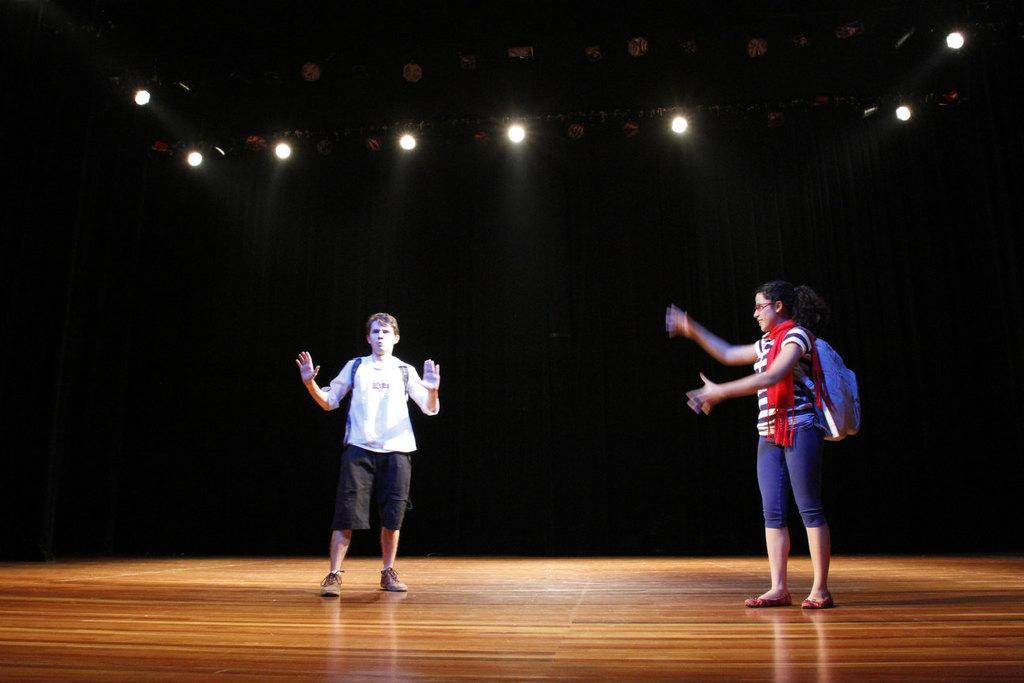In one or two sentences, can you explain what this image depicts? In this image we can see there are two people standing on the stage and wearing a bag. And at the top there are lights and it looks like a dark background. 